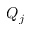Convert formula to latex. <formula><loc_0><loc_0><loc_500><loc_500>Q _ { j }</formula> 